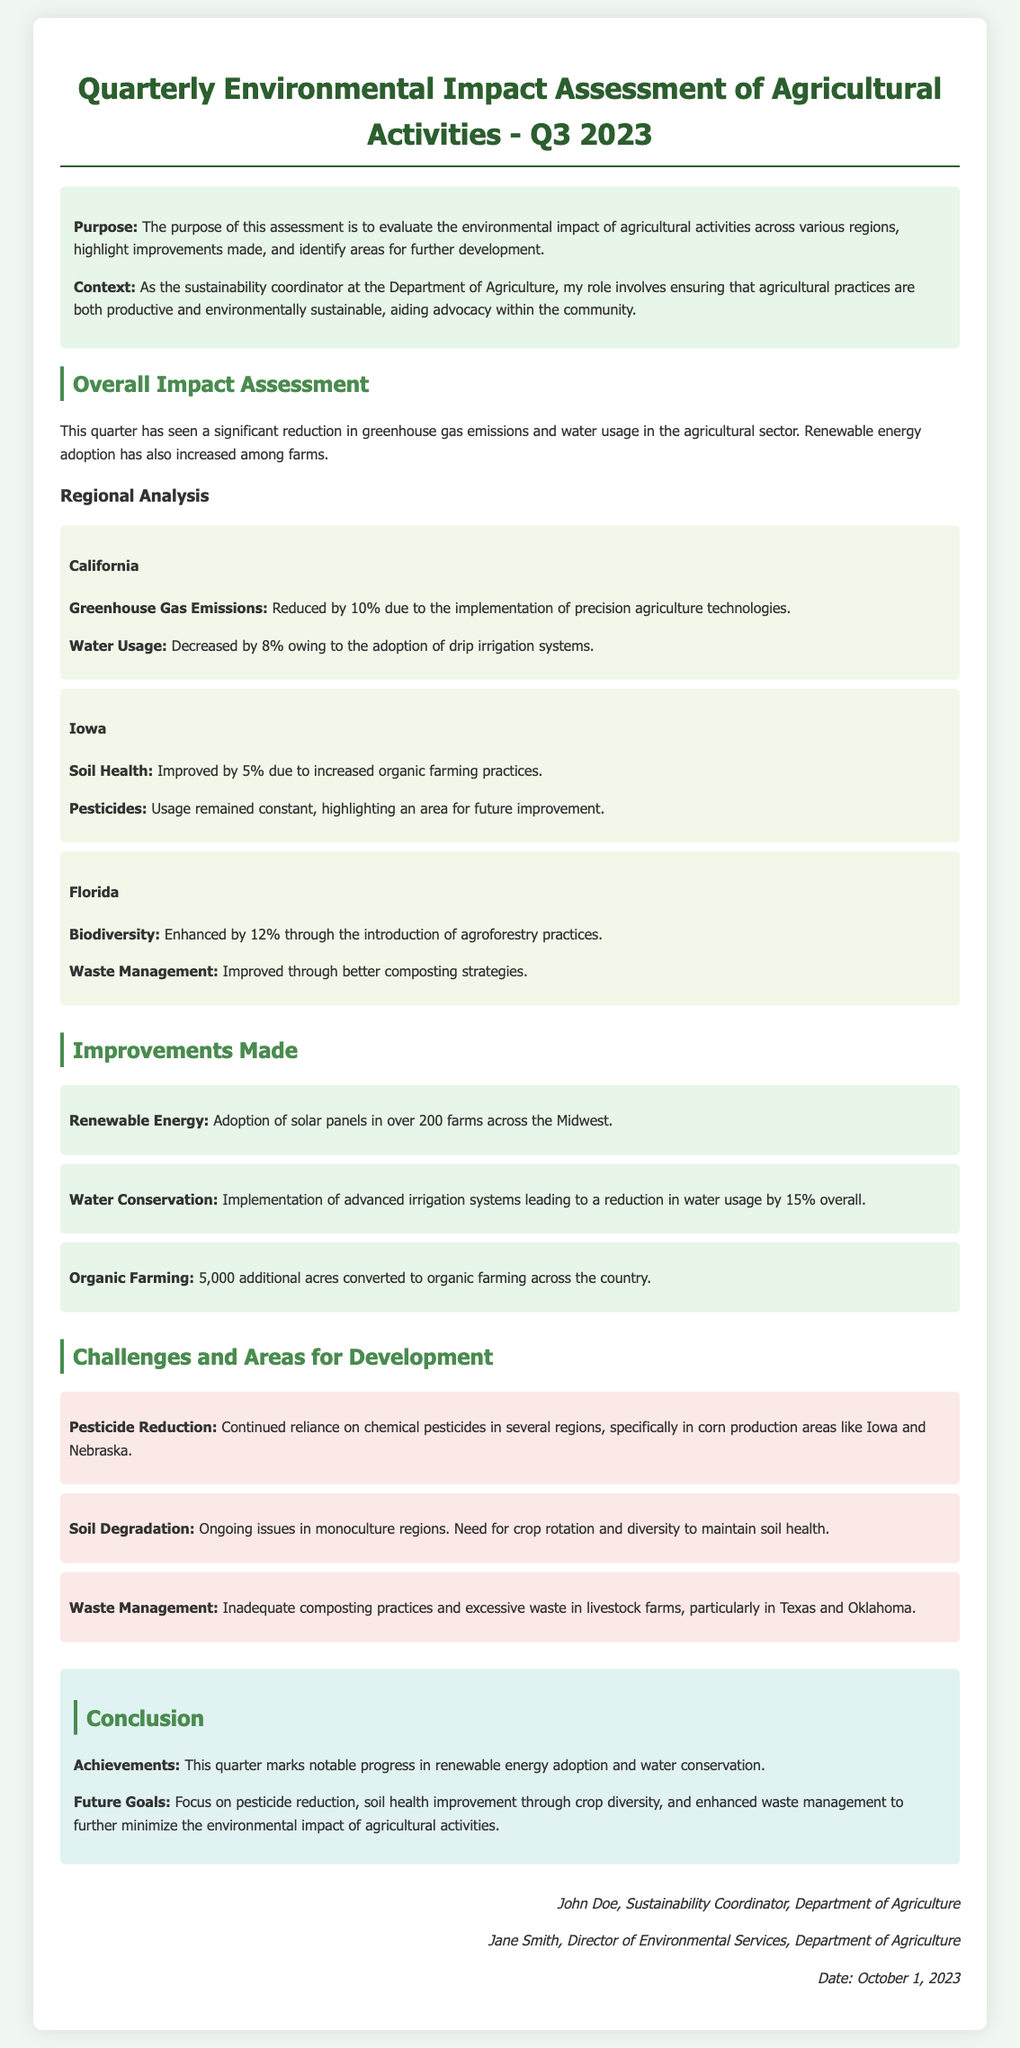What is the purpose of the assessment? The purpose is to evaluate the environmental impact of agricultural activities, highlight improvements, and identify areas for further development.
Answer: Evaluate environmental impact What percentage did greenhouse gas emissions reduce in California? The document states that greenhouse gas emissions in California reduced by 10%.
Answer: 10% What area had a 12% enhancement in biodiversity? The region with a 12% enhancement in biodiversity is Florida through agroforestry practices.
Answer: Florida How many farms in the Midwest adopted solar panels? The document mentions over 200 farms in the Midwest adopting solar panels.
Answer: 200 What challenge is identified regarding pesticide use? The ongoing reliance on chemical pesticides in corn production areas like Iowa and Nebraska is identified as a challenge.
Answer: Chemical pesticides What is the overall reduction in water usage due to advanced irrigation systems? The document notes a reduction in water usage by 15% overall due to advanced irrigation systems.
Answer: 15% Which region has improved soil health by 5%? Iowa is the region where soil health improved by 5% due to increased organic farming practices.
Answer: Iowa What future goal is mentioned regarding soil health? The future goal includes improving soil health through crop diversity and reducing reliance on monoculture practices.
Answer: Crop diversity Who signed the declaration? The signatories include John Doe and Jane Smith from the Department of Agriculture.
Answer: John Doe and Jane Smith 